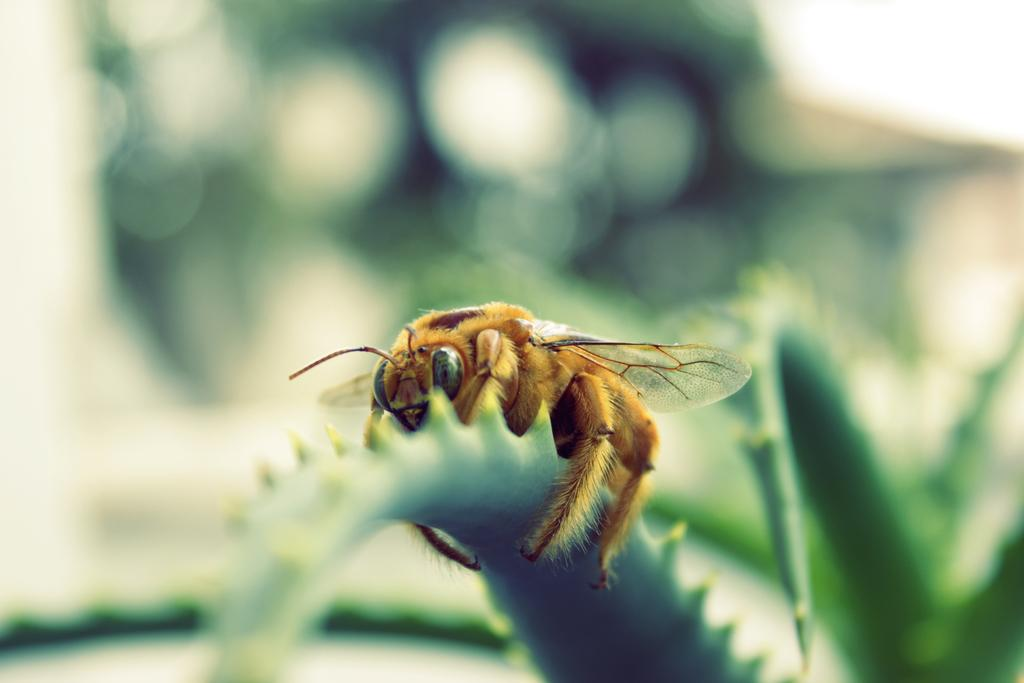What is the main subject of the image? There is a fly on a leaf in the image. How would you describe the background of the image? The background of the image is blurry. Can you identify any other elements in the image besides the fly? Yes, there is a plant visible in the background of the image. What position does the team play in the image? There is no team or position present in the image; it features a fly on a leaf and a blurry background with a plant. How does the fly wash its hands in the image? Flies do not have hands, and there is no indication in the image that the fly is washing anything. 